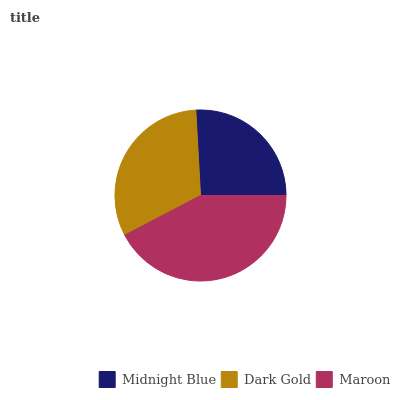Is Midnight Blue the minimum?
Answer yes or no. Yes. Is Maroon the maximum?
Answer yes or no. Yes. Is Dark Gold the minimum?
Answer yes or no. No. Is Dark Gold the maximum?
Answer yes or no. No. Is Dark Gold greater than Midnight Blue?
Answer yes or no. Yes. Is Midnight Blue less than Dark Gold?
Answer yes or no. Yes. Is Midnight Blue greater than Dark Gold?
Answer yes or no. No. Is Dark Gold less than Midnight Blue?
Answer yes or no. No. Is Dark Gold the high median?
Answer yes or no. Yes. Is Dark Gold the low median?
Answer yes or no. Yes. Is Midnight Blue the high median?
Answer yes or no. No. Is Maroon the low median?
Answer yes or no. No. 